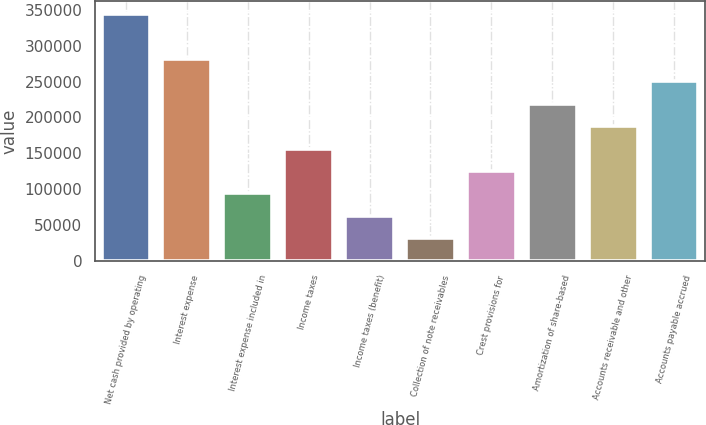Convert chart. <chart><loc_0><loc_0><loc_500><loc_500><bar_chart><fcel>Net cash provided by operating<fcel>Interest expense<fcel>Interest expense included in<fcel>Income taxes<fcel>Income taxes (benefit)<fcel>Collection of note receivables<fcel>Crest provisions for<fcel>Amortization of share-based<fcel>Accounts receivable and other<fcel>Accounts payable accrued<nl><fcel>344644<fcel>281982<fcel>93996.2<fcel>156658<fcel>62665.2<fcel>31334.3<fcel>125327<fcel>219320<fcel>187989<fcel>250651<nl></chart> 